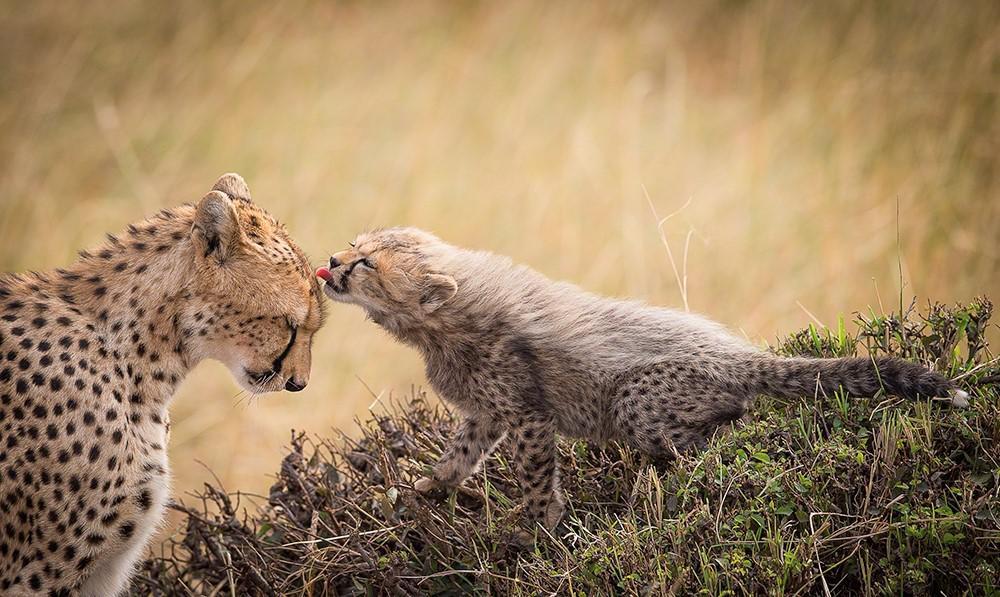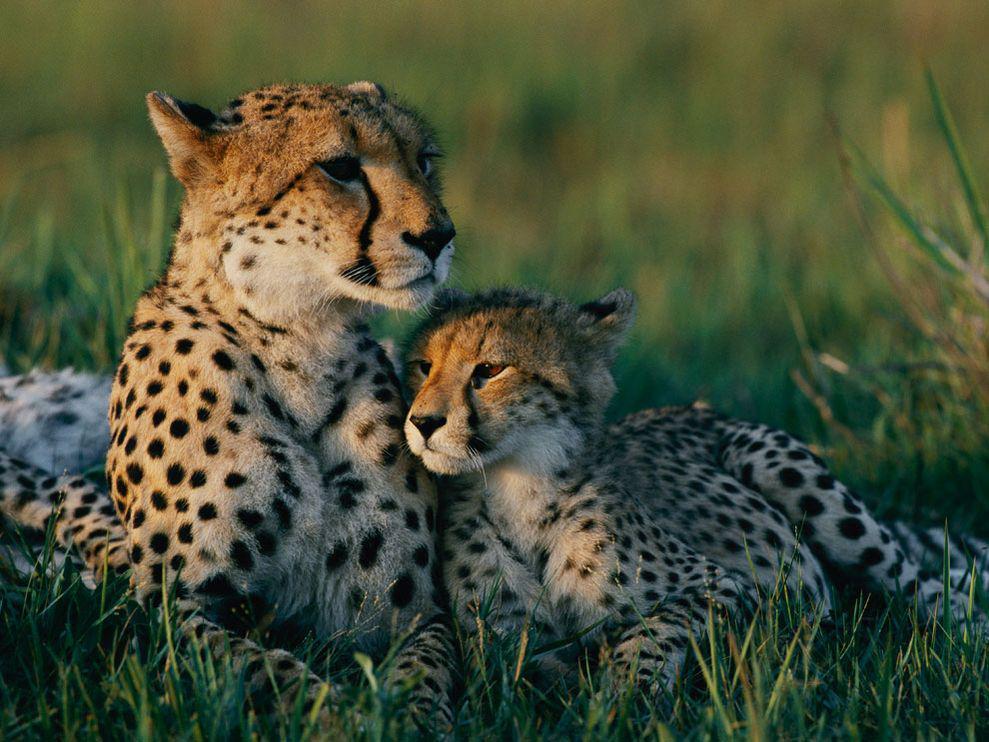The first image is the image on the left, the second image is the image on the right. Considering the images on both sides, is "Each image shows exactly two cheetahs." valid? Answer yes or no. Yes. 